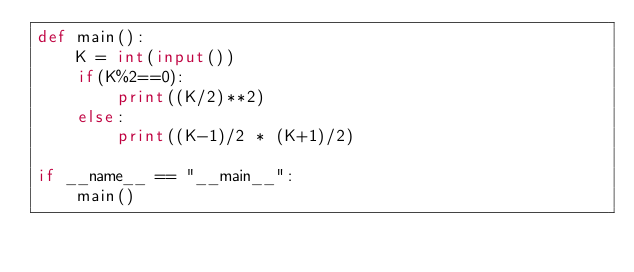<code> <loc_0><loc_0><loc_500><loc_500><_Python_>def main():
    K = int(input())
    if(K%2==0):
        print((K/2)**2)
    else:
        print((K-1)/2 * (K+1)/2)

if __name__ == "__main__":
    main()</code> 